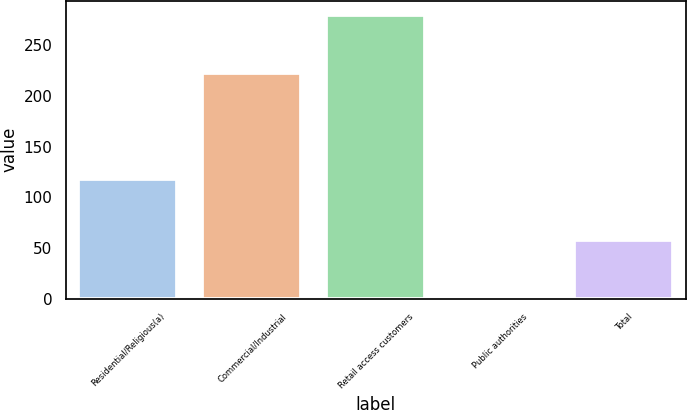Convert chart to OTSL. <chart><loc_0><loc_0><loc_500><loc_500><bar_chart><fcel>Residential/Religious(a)<fcel>Commercial/Industrial<fcel>Retail access customers<fcel>Public authorities<fcel>Total<nl><fcel>118<fcel>223<fcel>280<fcel>3<fcel>58<nl></chart> 